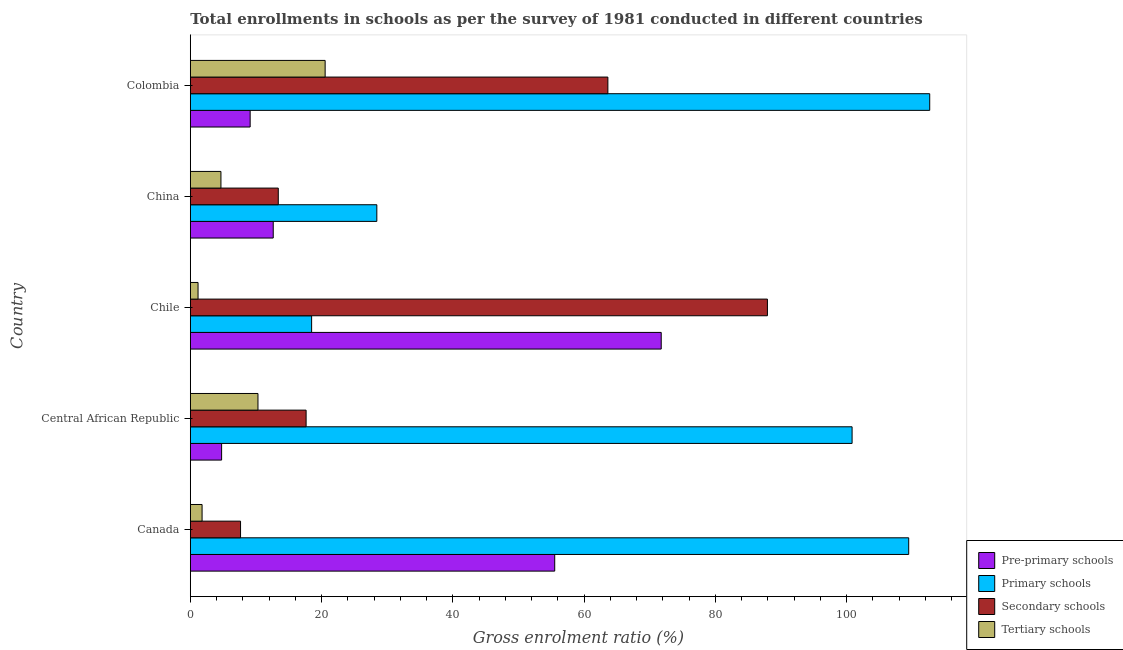How many bars are there on the 2nd tick from the bottom?
Offer a very short reply. 4. What is the label of the 5th group of bars from the top?
Give a very brief answer. Canada. What is the gross enrolment ratio in primary schools in Colombia?
Make the answer very short. 112.64. Across all countries, what is the maximum gross enrolment ratio in secondary schools?
Provide a short and direct response. 87.92. Across all countries, what is the minimum gross enrolment ratio in pre-primary schools?
Make the answer very short. 4.77. In which country was the gross enrolment ratio in pre-primary schools maximum?
Ensure brevity in your answer.  Chile. In which country was the gross enrolment ratio in secondary schools minimum?
Your response must be concise. Canada. What is the total gross enrolment ratio in tertiary schools in the graph?
Make the answer very short. 38.49. What is the difference between the gross enrolment ratio in pre-primary schools in Canada and that in Colombia?
Give a very brief answer. 46.4. What is the difference between the gross enrolment ratio in tertiary schools in Colombia and the gross enrolment ratio in primary schools in Central African Republic?
Offer a terse response. -80.28. What is the average gross enrolment ratio in tertiary schools per country?
Provide a succinct answer. 7.7. What is the difference between the gross enrolment ratio in primary schools and gross enrolment ratio in secondary schools in Canada?
Ensure brevity in your answer.  101.79. What is the ratio of the gross enrolment ratio in tertiary schools in Central African Republic to that in Chile?
Give a very brief answer. 8.73. Is the gross enrolment ratio in pre-primary schools in Chile less than that in China?
Offer a terse response. No. Is the difference between the gross enrolment ratio in pre-primary schools in China and Colombia greater than the difference between the gross enrolment ratio in tertiary schools in China and Colombia?
Give a very brief answer. Yes. What is the difference between the highest and the second highest gross enrolment ratio in secondary schools?
Your response must be concise. 24.3. What is the difference between the highest and the lowest gross enrolment ratio in primary schools?
Provide a short and direct response. 94.16. In how many countries, is the gross enrolment ratio in primary schools greater than the average gross enrolment ratio in primary schools taken over all countries?
Make the answer very short. 3. Is the sum of the gross enrolment ratio in pre-primary schools in China and Colombia greater than the maximum gross enrolment ratio in secondary schools across all countries?
Your response must be concise. No. Is it the case that in every country, the sum of the gross enrolment ratio in pre-primary schools and gross enrolment ratio in secondary schools is greater than the sum of gross enrolment ratio in tertiary schools and gross enrolment ratio in primary schools?
Your answer should be compact. No. What does the 4th bar from the top in Chile represents?
Your answer should be compact. Pre-primary schools. What does the 4th bar from the bottom in Chile represents?
Make the answer very short. Tertiary schools. How many bars are there?
Offer a terse response. 20. Are all the bars in the graph horizontal?
Your answer should be compact. Yes. How many legend labels are there?
Make the answer very short. 4. How are the legend labels stacked?
Offer a very short reply. Vertical. What is the title of the graph?
Your answer should be compact. Total enrollments in schools as per the survey of 1981 conducted in different countries. Does "WFP" appear as one of the legend labels in the graph?
Offer a terse response. No. What is the label or title of the Y-axis?
Provide a short and direct response. Country. What is the Gross enrolment ratio (%) in Pre-primary schools in Canada?
Your response must be concise. 55.52. What is the Gross enrolment ratio (%) in Primary schools in Canada?
Ensure brevity in your answer.  109.44. What is the Gross enrolment ratio (%) in Secondary schools in Canada?
Your answer should be compact. 7.66. What is the Gross enrolment ratio (%) in Tertiary schools in Canada?
Your answer should be very brief. 1.79. What is the Gross enrolment ratio (%) in Pre-primary schools in Central African Republic?
Ensure brevity in your answer.  4.77. What is the Gross enrolment ratio (%) in Primary schools in Central African Republic?
Your response must be concise. 100.82. What is the Gross enrolment ratio (%) of Secondary schools in Central African Republic?
Make the answer very short. 17.64. What is the Gross enrolment ratio (%) of Tertiary schools in Central African Republic?
Keep it short and to the point. 10.31. What is the Gross enrolment ratio (%) of Pre-primary schools in Chile?
Your answer should be very brief. 71.74. What is the Gross enrolment ratio (%) of Primary schools in Chile?
Your answer should be compact. 18.48. What is the Gross enrolment ratio (%) in Secondary schools in Chile?
Offer a terse response. 87.92. What is the Gross enrolment ratio (%) in Tertiary schools in Chile?
Provide a short and direct response. 1.18. What is the Gross enrolment ratio (%) in Pre-primary schools in China?
Provide a succinct answer. 12.63. What is the Gross enrolment ratio (%) in Primary schools in China?
Keep it short and to the point. 28.42. What is the Gross enrolment ratio (%) in Secondary schools in China?
Your response must be concise. 13.4. What is the Gross enrolment ratio (%) in Tertiary schools in China?
Your response must be concise. 4.67. What is the Gross enrolment ratio (%) of Pre-primary schools in Colombia?
Make the answer very short. 9.12. What is the Gross enrolment ratio (%) in Primary schools in Colombia?
Offer a terse response. 112.64. What is the Gross enrolment ratio (%) in Secondary schools in Colombia?
Provide a succinct answer. 63.61. What is the Gross enrolment ratio (%) in Tertiary schools in Colombia?
Your response must be concise. 20.54. Across all countries, what is the maximum Gross enrolment ratio (%) of Pre-primary schools?
Ensure brevity in your answer.  71.74. Across all countries, what is the maximum Gross enrolment ratio (%) of Primary schools?
Keep it short and to the point. 112.64. Across all countries, what is the maximum Gross enrolment ratio (%) of Secondary schools?
Offer a very short reply. 87.92. Across all countries, what is the maximum Gross enrolment ratio (%) in Tertiary schools?
Offer a terse response. 20.54. Across all countries, what is the minimum Gross enrolment ratio (%) in Pre-primary schools?
Offer a very short reply. 4.77. Across all countries, what is the minimum Gross enrolment ratio (%) of Primary schools?
Make the answer very short. 18.48. Across all countries, what is the minimum Gross enrolment ratio (%) in Secondary schools?
Your response must be concise. 7.66. Across all countries, what is the minimum Gross enrolment ratio (%) of Tertiary schools?
Provide a succinct answer. 1.18. What is the total Gross enrolment ratio (%) in Pre-primary schools in the graph?
Offer a terse response. 153.78. What is the total Gross enrolment ratio (%) of Primary schools in the graph?
Keep it short and to the point. 369.8. What is the total Gross enrolment ratio (%) of Secondary schools in the graph?
Your answer should be compact. 190.24. What is the total Gross enrolment ratio (%) in Tertiary schools in the graph?
Your answer should be very brief. 38.49. What is the difference between the Gross enrolment ratio (%) of Pre-primary schools in Canada and that in Central African Republic?
Ensure brevity in your answer.  50.75. What is the difference between the Gross enrolment ratio (%) in Primary schools in Canada and that in Central African Republic?
Provide a succinct answer. 8.63. What is the difference between the Gross enrolment ratio (%) in Secondary schools in Canada and that in Central African Republic?
Your response must be concise. -9.99. What is the difference between the Gross enrolment ratio (%) in Tertiary schools in Canada and that in Central African Republic?
Provide a succinct answer. -8.51. What is the difference between the Gross enrolment ratio (%) in Pre-primary schools in Canada and that in Chile?
Offer a very short reply. -16.22. What is the difference between the Gross enrolment ratio (%) in Primary schools in Canada and that in Chile?
Make the answer very short. 90.96. What is the difference between the Gross enrolment ratio (%) in Secondary schools in Canada and that in Chile?
Provide a short and direct response. -80.26. What is the difference between the Gross enrolment ratio (%) in Tertiary schools in Canada and that in Chile?
Offer a terse response. 0.61. What is the difference between the Gross enrolment ratio (%) of Pre-primary schools in Canada and that in China?
Your answer should be compact. 42.88. What is the difference between the Gross enrolment ratio (%) of Primary schools in Canada and that in China?
Offer a terse response. 81.03. What is the difference between the Gross enrolment ratio (%) in Secondary schools in Canada and that in China?
Make the answer very short. -5.75. What is the difference between the Gross enrolment ratio (%) of Tertiary schools in Canada and that in China?
Provide a short and direct response. -2.87. What is the difference between the Gross enrolment ratio (%) in Pre-primary schools in Canada and that in Colombia?
Your answer should be very brief. 46.4. What is the difference between the Gross enrolment ratio (%) of Primary schools in Canada and that in Colombia?
Your response must be concise. -3.2. What is the difference between the Gross enrolment ratio (%) in Secondary schools in Canada and that in Colombia?
Give a very brief answer. -55.96. What is the difference between the Gross enrolment ratio (%) of Tertiary schools in Canada and that in Colombia?
Keep it short and to the point. -18.75. What is the difference between the Gross enrolment ratio (%) of Pre-primary schools in Central African Republic and that in Chile?
Your answer should be very brief. -66.97. What is the difference between the Gross enrolment ratio (%) in Primary schools in Central African Republic and that in Chile?
Provide a short and direct response. 82.33. What is the difference between the Gross enrolment ratio (%) of Secondary schools in Central African Republic and that in Chile?
Your response must be concise. -70.28. What is the difference between the Gross enrolment ratio (%) of Tertiary schools in Central African Republic and that in Chile?
Keep it short and to the point. 9.13. What is the difference between the Gross enrolment ratio (%) of Pre-primary schools in Central African Republic and that in China?
Your answer should be compact. -7.86. What is the difference between the Gross enrolment ratio (%) of Primary schools in Central African Republic and that in China?
Your answer should be compact. 72.4. What is the difference between the Gross enrolment ratio (%) in Secondary schools in Central African Republic and that in China?
Your response must be concise. 4.24. What is the difference between the Gross enrolment ratio (%) in Tertiary schools in Central African Republic and that in China?
Your answer should be very brief. 5.64. What is the difference between the Gross enrolment ratio (%) in Pre-primary schools in Central African Republic and that in Colombia?
Your answer should be very brief. -4.35. What is the difference between the Gross enrolment ratio (%) of Primary schools in Central African Republic and that in Colombia?
Offer a terse response. -11.83. What is the difference between the Gross enrolment ratio (%) of Secondary schools in Central African Republic and that in Colombia?
Your answer should be very brief. -45.97. What is the difference between the Gross enrolment ratio (%) in Tertiary schools in Central African Republic and that in Colombia?
Your response must be concise. -10.23. What is the difference between the Gross enrolment ratio (%) in Pre-primary schools in Chile and that in China?
Offer a very short reply. 59.11. What is the difference between the Gross enrolment ratio (%) of Primary schools in Chile and that in China?
Make the answer very short. -9.93. What is the difference between the Gross enrolment ratio (%) in Secondary schools in Chile and that in China?
Give a very brief answer. 74.52. What is the difference between the Gross enrolment ratio (%) in Tertiary schools in Chile and that in China?
Your response must be concise. -3.49. What is the difference between the Gross enrolment ratio (%) in Pre-primary schools in Chile and that in Colombia?
Your answer should be very brief. 62.62. What is the difference between the Gross enrolment ratio (%) in Primary schools in Chile and that in Colombia?
Your answer should be very brief. -94.16. What is the difference between the Gross enrolment ratio (%) in Secondary schools in Chile and that in Colombia?
Offer a terse response. 24.31. What is the difference between the Gross enrolment ratio (%) in Tertiary schools in Chile and that in Colombia?
Give a very brief answer. -19.36. What is the difference between the Gross enrolment ratio (%) of Pre-primary schools in China and that in Colombia?
Your response must be concise. 3.51. What is the difference between the Gross enrolment ratio (%) in Primary schools in China and that in Colombia?
Ensure brevity in your answer.  -84.23. What is the difference between the Gross enrolment ratio (%) of Secondary schools in China and that in Colombia?
Keep it short and to the point. -50.21. What is the difference between the Gross enrolment ratio (%) in Tertiary schools in China and that in Colombia?
Your answer should be very brief. -15.87. What is the difference between the Gross enrolment ratio (%) in Pre-primary schools in Canada and the Gross enrolment ratio (%) in Primary schools in Central African Republic?
Ensure brevity in your answer.  -45.3. What is the difference between the Gross enrolment ratio (%) of Pre-primary schools in Canada and the Gross enrolment ratio (%) of Secondary schools in Central African Republic?
Your answer should be compact. 37.87. What is the difference between the Gross enrolment ratio (%) in Pre-primary schools in Canada and the Gross enrolment ratio (%) in Tertiary schools in Central African Republic?
Offer a very short reply. 45.21. What is the difference between the Gross enrolment ratio (%) in Primary schools in Canada and the Gross enrolment ratio (%) in Secondary schools in Central African Republic?
Make the answer very short. 91.8. What is the difference between the Gross enrolment ratio (%) of Primary schools in Canada and the Gross enrolment ratio (%) of Tertiary schools in Central African Republic?
Offer a very short reply. 99.13. What is the difference between the Gross enrolment ratio (%) in Secondary schools in Canada and the Gross enrolment ratio (%) in Tertiary schools in Central African Republic?
Your response must be concise. -2.65. What is the difference between the Gross enrolment ratio (%) of Pre-primary schools in Canada and the Gross enrolment ratio (%) of Primary schools in Chile?
Ensure brevity in your answer.  37.03. What is the difference between the Gross enrolment ratio (%) of Pre-primary schools in Canada and the Gross enrolment ratio (%) of Secondary schools in Chile?
Make the answer very short. -32.4. What is the difference between the Gross enrolment ratio (%) in Pre-primary schools in Canada and the Gross enrolment ratio (%) in Tertiary schools in Chile?
Provide a succinct answer. 54.34. What is the difference between the Gross enrolment ratio (%) in Primary schools in Canada and the Gross enrolment ratio (%) in Secondary schools in Chile?
Ensure brevity in your answer.  21.52. What is the difference between the Gross enrolment ratio (%) of Primary schools in Canada and the Gross enrolment ratio (%) of Tertiary schools in Chile?
Ensure brevity in your answer.  108.26. What is the difference between the Gross enrolment ratio (%) in Secondary schools in Canada and the Gross enrolment ratio (%) in Tertiary schools in Chile?
Keep it short and to the point. 6.47. What is the difference between the Gross enrolment ratio (%) in Pre-primary schools in Canada and the Gross enrolment ratio (%) in Primary schools in China?
Keep it short and to the point. 27.1. What is the difference between the Gross enrolment ratio (%) of Pre-primary schools in Canada and the Gross enrolment ratio (%) of Secondary schools in China?
Your response must be concise. 42.11. What is the difference between the Gross enrolment ratio (%) of Pre-primary schools in Canada and the Gross enrolment ratio (%) of Tertiary schools in China?
Your answer should be compact. 50.85. What is the difference between the Gross enrolment ratio (%) in Primary schools in Canada and the Gross enrolment ratio (%) in Secondary schools in China?
Your answer should be very brief. 96.04. What is the difference between the Gross enrolment ratio (%) of Primary schools in Canada and the Gross enrolment ratio (%) of Tertiary schools in China?
Provide a succinct answer. 104.78. What is the difference between the Gross enrolment ratio (%) of Secondary schools in Canada and the Gross enrolment ratio (%) of Tertiary schools in China?
Make the answer very short. 2.99. What is the difference between the Gross enrolment ratio (%) of Pre-primary schools in Canada and the Gross enrolment ratio (%) of Primary schools in Colombia?
Your answer should be compact. -57.13. What is the difference between the Gross enrolment ratio (%) in Pre-primary schools in Canada and the Gross enrolment ratio (%) in Secondary schools in Colombia?
Provide a succinct answer. -8.1. What is the difference between the Gross enrolment ratio (%) of Pre-primary schools in Canada and the Gross enrolment ratio (%) of Tertiary schools in Colombia?
Your answer should be compact. 34.98. What is the difference between the Gross enrolment ratio (%) of Primary schools in Canada and the Gross enrolment ratio (%) of Secondary schools in Colombia?
Provide a short and direct response. 45.83. What is the difference between the Gross enrolment ratio (%) of Primary schools in Canada and the Gross enrolment ratio (%) of Tertiary schools in Colombia?
Provide a short and direct response. 88.9. What is the difference between the Gross enrolment ratio (%) of Secondary schools in Canada and the Gross enrolment ratio (%) of Tertiary schools in Colombia?
Ensure brevity in your answer.  -12.89. What is the difference between the Gross enrolment ratio (%) in Pre-primary schools in Central African Republic and the Gross enrolment ratio (%) in Primary schools in Chile?
Ensure brevity in your answer.  -13.71. What is the difference between the Gross enrolment ratio (%) of Pre-primary schools in Central African Republic and the Gross enrolment ratio (%) of Secondary schools in Chile?
Ensure brevity in your answer.  -83.15. What is the difference between the Gross enrolment ratio (%) of Pre-primary schools in Central African Republic and the Gross enrolment ratio (%) of Tertiary schools in Chile?
Offer a very short reply. 3.59. What is the difference between the Gross enrolment ratio (%) of Primary schools in Central African Republic and the Gross enrolment ratio (%) of Secondary schools in Chile?
Offer a terse response. 12.9. What is the difference between the Gross enrolment ratio (%) in Primary schools in Central African Republic and the Gross enrolment ratio (%) in Tertiary schools in Chile?
Offer a terse response. 99.64. What is the difference between the Gross enrolment ratio (%) in Secondary schools in Central African Republic and the Gross enrolment ratio (%) in Tertiary schools in Chile?
Your response must be concise. 16.46. What is the difference between the Gross enrolment ratio (%) of Pre-primary schools in Central African Republic and the Gross enrolment ratio (%) of Primary schools in China?
Offer a terse response. -23.65. What is the difference between the Gross enrolment ratio (%) of Pre-primary schools in Central African Republic and the Gross enrolment ratio (%) of Secondary schools in China?
Your response must be concise. -8.63. What is the difference between the Gross enrolment ratio (%) of Pre-primary schools in Central African Republic and the Gross enrolment ratio (%) of Tertiary schools in China?
Provide a succinct answer. 0.1. What is the difference between the Gross enrolment ratio (%) in Primary schools in Central African Republic and the Gross enrolment ratio (%) in Secondary schools in China?
Make the answer very short. 87.41. What is the difference between the Gross enrolment ratio (%) in Primary schools in Central African Republic and the Gross enrolment ratio (%) in Tertiary schools in China?
Offer a very short reply. 96.15. What is the difference between the Gross enrolment ratio (%) of Secondary schools in Central African Republic and the Gross enrolment ratio (%) of Tertiary schools in China?
Your response must be concise. 12.98. What is the difference between the Gross enrolment ratio (%) in Pre-primary schools in Central African Republic and the Gross enrolment ratio (%) in Primary schools in Colombia?
Offer a very short reply. -107.87. What is the difference between the Gross enrolment ratio (%) in Pre-primary schools in Central African Republic and the Gross enrolment ratio (%) in Secondary schools in Colombia?
Your answer should be very brief. -58.84. What is the difference between the Gross enrolment ratio (%) of Pre-primary schools in Central African Republic and the Gross enrolment ratio (%) of Tertiary schools in Colombia?
Give a very brief answer. -15.77. What is the difference between the Gross enrolment ratio (%) in Primary schools in Central African Republic and the Gross enrolment ratio (%) in Secondary schools in Colombia?
Offer a very short reply. 37.2. What is the difference between the Gross enrolment ratio (%) in Primary schools in Central African Republic and the Gross enrolment ratio (%) in Tertiary schools in Colombia?
Your response must be concise. 80.28. What is the difference between the Gross enrolment ratio (%) of Secondary schools in Central African Republic and the Gross enrolment ratio (%) of Tertiary schools in Colombia?
Provide a short and direct response. -2.9. What is the difference between the Gross enrolment ratio (%) of Pre-primary schools in Chile and the Gross enrolment ratio (%) of Primary schools in China?
Offer a terse response. 43.32. What is the difference between the Gross enrolment ratio (%) in Pre-primary schools in Chile and the Gross enrolment ratio (%) in Secondary schools in China?
Ensure brevity in your answer.  58.34. What is the difference between the Gross enrolment ratio (%) in Pre-primary schools in Chile and the Gross enrolment ratio (%) in Tertiary schools in China?
Offer a very short reply. 67.07. What is the difference between the Gross enrolment ratio (%) of Primary schools in Chile and the Gross enrolment ratio (%) of Secondary schools in China?
Your answer should be compact. 5.08. What is the difference between the Gross enrolment ratio (%) in Primary schools in Chile and the Gross enrolment ratio (%) in Tertiary schools in China?
Give a very brief answer. 13.82. What is the difference between the Gross enrolment ratio (%) in Secondary schools in Chile and the Gross enrolment ratio (%) in Tertiary schools in China?
Your answer should be compact. 83.25. What is the difference between the Gross enrolment ratio (%) in Pre-primary schools in Chile and the Gross enrolment ratio (%) in Primary schools in Colombia?
Offer a terse response. -40.9. What is the difference between the Gross enrolment ratio (%) of Pre-primary schools in Chile and the Gross enrolment ratio (%) of Secondary schools in Colombia?
Provide a succinct answer. 8.13. What is the difference between the Gross enrolment ratio (%) of Pre-primary schools in Chile and the Gross enrolment ratio (%) of Tertiary schools in Colombia?
Provide a short and direct response. 51.2. What is the difference between the Gross enrolment ratio (%) in Primary schools in Chile and the Gross enrolment ratio (%) in Secondary schools in Colombia?
Your answer should be compact. -45.13. What is the difference between the Gross enrolment ratio (%) in Primary schools in Chile and the Gross enrolment ratio (%) in Tertiary schools in Colombia?
Give a very brief answer. -2.06. What is the difference between the Gross enrolment ratio (%) in Secondary schools in Chile and the Gross enrolment ratio (%) in Tertiary schools in Colombia?
Ensure brevity in your answer.  67.38. What is the difference between the Gross enrolment ratio (%) in Pre-primary schools in China and the Gross enrolment ratio (%) in Primary schools in Colombia?
Make the answer very short. -100.01. What is the difference between the Gross enrolment ratio (%) in Pre-primary schools in China and the Gross enrolment ratio (%) in Secondary schools in Colombia?
Offer a terse response. -50.98. What is the difference between the Gross enrolment ratio (%) in Pre-primary schools in China and the Gross enrolment ratio (%) in Tertiary schools in Colombia?
Provide a short and direct response. -7.91. What is the difference between the Gross enrolment ratio (%) in Primary schools in China and the Gross enrolment ratio (%) in Secondary schools in Colombia?
Your response must be concise. -35.2. What is the difference between the Gross enrolment ratio (%) in Primary schools in China and the Gross enrolment ratio (%) in Tertiary schools in Colombia?
Your answer should be compact. 7.87. What is the difference between the Gross enrolment ratio (%) in Secondary schools in China and the Gross enrolment ratio (%) in Tertiary schools in Colombia?
Keep it short and to the point. -7.14. What is the average Gross enrolment ratio (%) in Pre-primary schools per country?
Offer a terse response. 30.76. What is the average Gross enrolment ratio (%) in Primary schools per country?
Provide a short and direct response. 73.96. What is the average Gross enrolment ratio (%) of Secondary schools per country?
Give a very brief answer. 38.05. What is the average Gross enrolment ratio (%) of Tertiary schools per country?
Your answer should be very brief. 7.7. What is the difference between the Gross enrolment ratio (%) in Pre-primary schools and Gross enrolment ratio (%) in Primary schools in Canada?
Give a very brief answer. -53.93. What is the difference between the Gross enrolment ratio (%) in Pre-primary schools and Gross enrolment ratio (%) in Secondary schools in Canada?
Offer a terse response. 47.86. What is the difference between the Gross enrolment ratio (%) of Pre-primary schools and Gross enrolment ratio (%) of Tertiary schools in Canada?
Provide a short and direct response. 53.72. What is the difference between the Gross enrolment ratio (%) of Primary schools and Gross enrolment ratio (%) of Secondary schools in Canada?
Give a very brief answer. 101.79. What is the difference between the Gross enrolment ratio (%) in Primary schools and Gross enrolment ratio (%) in Tertiary schools in Canada?
Make the answer very short. 107.65. What is the difference between the Gross enrolment ratio (%) in Secondary schools and Gross enrolment ratio (%) in Tertiary schools in Canada?
Make the answer very short. 5.86. What is the difference between the Gross enrolment ratio (%) of Pre-primary schools and Gross enrolment ratio (%) of Primary schools in Central African Republic?
Offer a very short reply. -96.05. What is the difference between the Gross enrolment ratio (%) of Pre-primary schools and Gross enrolment ratio (%) of Secondary schools in Central African Republic?
Provide a succinct answer. -12.87. What is the difference between the Gross enrolment ratio (%) of Pre-primary schools and Gross enrolment ratio (%) of Tertiary schools in Central African Republic?
Provide a short and direct response. -5.54. What is the difference between the Gross enrolment ratio (%) in Primary schools and Gross enrolment ratio (%) in Secondary schools in Central African Republic?
Offer a very short reply. 83.17. What is the difference between the Gross enrolment ratio (%) of Primary schools and Gross enrolment ratio (%) of Tertiary schools in Central African Republic?
Make the answer very short. 90.51. What is the difference between the Gross enrolment ratio (%) of Secondary schools and Gross enrolment ratio (%) of Tertiary schools in Central African Republic?
Offer a very short reply. 7.33. What is the difference between the Gross enrolment ratio (%) of Pre-primary schools and Gross enrolment ratio (%) of Primary schools in Chile?
Your answer should be compact. 53.26. What is the difference between the Gross enrolment ratio (%) in Pre-primary schools and Gross enrolment ratio (%) in Secondary schools in Chile?
Your answer should be very brief. -16.18. What is the difference between the Gross enrolment ratio (%) in Pre-primary schools and Gross enrolment ratio (%) in Tertiary schools in Chile?
Offer a terse response. 70.56. What is the difference between the Gross enrolment ratio (%) in Primary schools and Gross enrolment ratio (%) in Secondary schools in Chile?
Your answer should be compact. -69.44. What is the difference between the Gross enrolment ratio (%) in Primary schools and Gross enrolment ratio (%) in Tertiary schools in Chile?
Offer a terse response. 17.3. What is the difference between the Gross enrolment ratio (%) in Secondary schools and Gross enrolment ratio (%) in Tertiary schools in Chile?
Your answer should be very brief. 86.74. What is the difference between the Gross enrolment ratio (%) of Pre-primary schools and Gross enrolment ratio (%) of Primary schools in China?
Offer a very short reply. -15.78. What is the difference between the Gross enrolment ratio (%) in Pre-primary schools and Gross enrolment ratio (%) in Secondary schools in China?
Provide a succinct answer. -0.77. What is the difference between the Gross enrolment ratio (%) in Pre-primary schools and Gross enrolment ratio (%) in Tertiary schools in China?
Your answer should be very brief. 7.97. What is the difference between the Gross enrolment ratio (%) of Primary schools and Gross enrolment ratio (%) of Secondary schools in China?
Make the answer very short. 15.01. What is the difference between the Gross enrolment ratio (%) in Primary schools and Gross enrolment ratio (%) in Tertiary schools in China?
Provide a short and direct response. 23.75. What is the difference between the Gross enrolment ratio (%) of Secondary schools and Gross enrolment ratio (%) of Tertiary schools in China?
Provide a succinct answer. 8.74. What is the difference between the Gross enrolment ratio (%) in Pre-primary schools and Gross enrolment ratio (%) in Primary schools in Colombia?
Ensure brevity in your answer.  -103.52. What is the difference between the Gross enrolment ratio (%) in Pre-primary schools and Gross enrolment ratio (%) in Secondary schools in Colombia?
Offer a terse response. -54.49. What is the difference between the Gross enrolment ratio (%) of Pre-primary schools and Gross enrolment ratio (%) of Tertiary schools in Colombia?
Your answer should be very brief. -11.42. What is the difference between the Gross enrolment ratio (%) of Primary schools and Gross enrolment ratio (%) of Secondary schools in Colombia?
Your response must be concise. 49.03. What is the difference between the Gross enrolment ratio (%) in Primary schools and Gross enrolment ratio (%) in Tertiary schools in Colombia?
Provide a succinct answer. 92.1. What is the difference between the Gross enrolment ratio (%) of Secondary schools and Gross enrolment ratio (%) of Tertiary schools in Colombia?
Offer a terse response. 43.07. What is the ratio of the Gross enrolment ratio (%) of Pre-primary schools in Canada to that in Central African Republic?
Your answer should be compact. 11.64. What is the ratio of the Gross enrolment ratio (%) of Primary schools in Canada to that in Central African Republic?
Provide a short and direct response. 1.09. What is the ratio of the Gross enrolment ratio (%) of Secondary schools in Canada to that in Central African Republic?
Make the answer very short. 0.43. What is the ratio of the Gross enrolment ratio (%) of Tertiary schools in Canada to that in Central African Republic?
Offer a very short reply. 0.17. What is the ratio of the Gross enrolment ratio (%) of Pre-primary schools in Canada to that in Chile?
Offer a terse response. 0.77. What is the ratio of the Gross enrolment ratio (%) of Primary schools in Canada to that in Chile?
Your response must be concise. 5.92. What is the ratio of the Gross enrolment ratio (%) of Secondary schools in Canada to that in Chile?
Your answer should be very brief. 0.09. What is the ratio of the Gross enrolment ratio (%) in Tertiary schools in Canada to that in Chile?
Your answer should be very brief. 1.52. What is the ratio of the Gross enrolment ratio (%) in Pre-primary schools in Canada to that in China?
Offer a very short reply. 4.39. What is the ratio of the Gross enrolment ratio (%) in Primary schools in Canada to that in China?
Offer a terse response. 3.85. What is the ratio of the Gross enrolment ratio (%) in Secondary schools in Canada to that in China?
Ensure brevity in your answer.  0.57. What is the ratio of the Gross enrolment ratio (%) of Tertiary schools in Canada to that in China?
Give a very brief answer. 0.38. What is the ratio of the Gross enrolment ratio (%) of Pre-primary schools in Canada to that in Colombia?
Offer a terse response. 6.09. What is the ratio of the Gross enrolment ratio (%) in Primary schools in Canada to that in Colombia?
Your answer should be compact. 0.97. What is the ratio of the Gross enrolment ratio (%) of Secondary schools in Canada to that in Colombia?
Give a very brief answer. 0.12. What is the ratio of the Gross enrolment ratio (%) in Tertiary schools in Canada to that in Colombia?
Provide a succinct answer. 0.09. What is the ratio of the Gross enrolment ratio (%) of Pre-primary schools in Central African Republic to that in Chile?
Your response must be concise. 0.07. What is the ratio of the Gross enrolment ratio (%) in Primary schools in Central African Republic to that in Chile?
Provide a succinct answer. 5.45. What is the ratio of the Gross enrolment ratio (%) of Secondary schools in Central African Republic to that in Chile?
Make the answer very short. 0.2. What is the ratio of the Gross enrolment ratio (%) in Tertiary schools in Central African Republic to that in Chile?
Your response must be concise. 8.73. What is the ratio of the Gross enrolment ratio (%) of Pre-primary schools in Central African Republic to that in China?
Your response must be concise. 0.38. What is the ratio of the Gross enrolment ratio (%) in Primary schools in Central African Republic to that in China?
Offer a very short reply. 3.55. What is the ratio of the Gross enrolment ratio (%) in Secondary schools in Central African Republic to that in China?
Keep it short and to the point. 1.32. What is the ratio of the Gross enrolment ratio (%) of Tertiary schools in Central African Republic to that in China?
Your response must be concise. 2.21. What is the ratio of the Gross enrolment ratio (%) in Pre-primary schools in Central African Republic to that in Colombia?
Offer a very short reply. 0.52. What is the ratio of the Gross enrolment ratio (%) in Primary schools in Central African Republic to that in Colombia?
Your answer should be very brief. 0.9. What is the ratio of the Gross enrolment ratio (%) in Secondary schools in Central African Republic to that in Colombia?
Ensure brevity in your answer.  0.28. What is the ratio of the Gross enrolment ratio (%) of Tertiary schools in Central African Republic to that in Colombia?
Keep it short and to the point. 0.5. What is the ratio of the Gross enrolment ratio (%) in Pre-primary schools in Chile to that in China?
Keep it short and to the point. 5.68. What is the ratio of the Gross enrolment ratio (%) of Primary schools in Chile to that in China?
Provide a succinct answer. 0.65. What is the ratio of the Gross enrolment ratio (%) of Secondary schools in Chile to that in China?
Provide a short and direct response. 6.56. What is the ratio of the Gross enrolment ratio (%) in Tertiary schools in Chile to that in China?
Keep it short and to the point. 0.25. What is the ratio of the Gross enrolment ratio (%) in Pre-primary schools in Chile to that in Colombia?
Give a very brief answer. 7.87. What is the ratio of the Gross enrolment ratio (%) of Primary schools in Chile to that in Colombia?
Keep it short and to the point. 0.16. What is the ratio of the Gross enrolment ratio (%) of Secondary schools in Chile to that in Colombia?
Ensure brevity in your answer.  1.38. What is the ratio of the Gross enrolment ratio (%) in Tertiary schools in Chile to that in Colombia?
Keep it short and to the point. 0.06. What is the ratio of the Gross enrolment ratio (%) of Pre-primary schools in China to that in Colombia?
Give a very brief answer. 1.39. What is the ratio of the Gross enrolment ratio (%) in Primary schools in China to that in Colombia?
Provide a short and direct response. 0.25. What is the ratio of the Gross enrolment ratio (%) in Secondary schools in China to that in Colombia?
Your answer should be compact. 0.21. What is the ratio of the Gross enrolment ratio (%) of Tertiary schools in China to that in Colombia?
Provide a short and direct response. 0.23. What is the difference between the highest and the second highest Gross enrolment ratio (%) in Pre-primary schools?
Provide a short and direct response. 16.22. What is the difference between the highest and the second highest Gross enrolment ratio (%) of Primary schools?
Keep it short and to the point. 3.2. What is the difference between the highest and the second highest Gross enrolment ratio (%) in Secondary schools?
Offer a very short reply. 24.31. What is the difference between the highest and the second highest Gross enrolment ratio (%) of Tertiary schools?
Offer a very short reply. 10.23. What is the difference between the highest and the lowest Gross enrolment ratio (%) of Pre-primary schools?
Give a very brief answer. 66.97. What is the difference between the highest and the lowest Gross enrolment ratio (%) in Primary schools?
Give a very brief answer. 94.16. What is the difference between the highest and the lowest Gross enrolment ratio (%) in Secondary schools?
Provide a short and direct response. 80.26. What is the difference between the highest and the lowest Gross enrolment ratio (%) in Tertiary schools?
Provide a succinct answer. 19.36. 